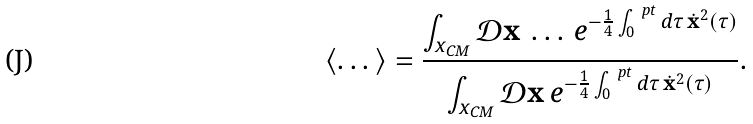<formula> <loc_0><loc_0><loc_500><loc_500>\langle \dots \rangle = \frac { \int _ { x _ { \text {CM} } } \mathcal { D } \mathbf x \, \dots \, e ^ { - \frac { 1 } { 4 } \int _ { 0 } ^ { \ p t } d \tau \, \dot { \mathbf x } ^ { 2 } ( \tau ) } } { \int _ { x _ { \text {CM} } } \mathcal { D } \mathbf x \, e ^ { - \frac { 1 } { 4 } \int _ { 0 } ^ { \ p t } d \tau \, \dot { \mathbf x } ^ { 2 } ( \tau ) } } .</formula> 